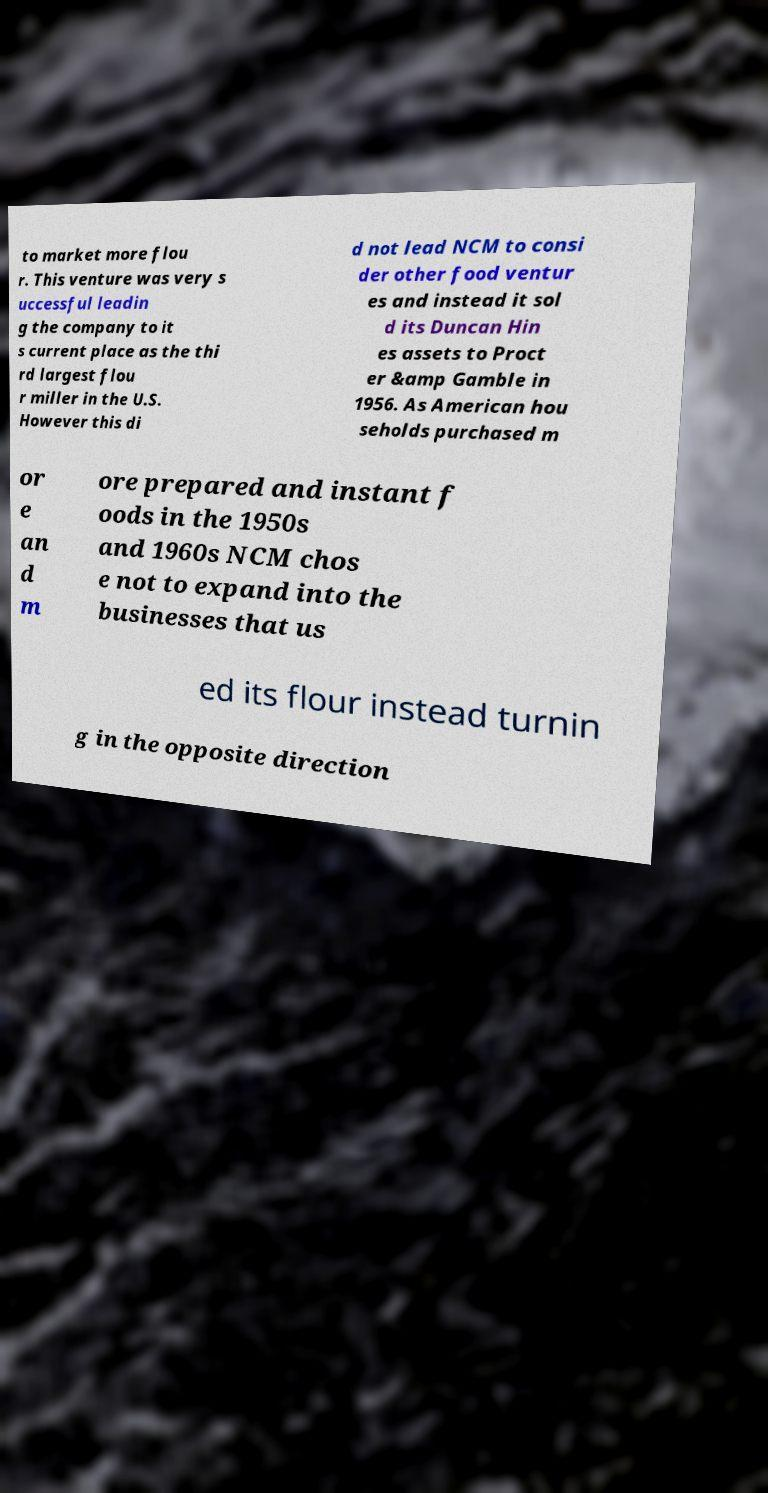Could you extract and type out the text from this image? to market more flou r. This venture was very s uccessful leadin g the company to it s current place as the thi rd largest flou r miller in the U.S. However this di d not lead NCM to consi der other food ventur es and instead it sol d its Duncan Hin es assets to Proct er &amp Gamble in 1956. As American hou seholds purchased m or e an d m ore prepared and instant f oods in the 1950s and 1960s NCM chos e not to expand into the businesses that us ed its flour instead turnin g in the opposite direction 